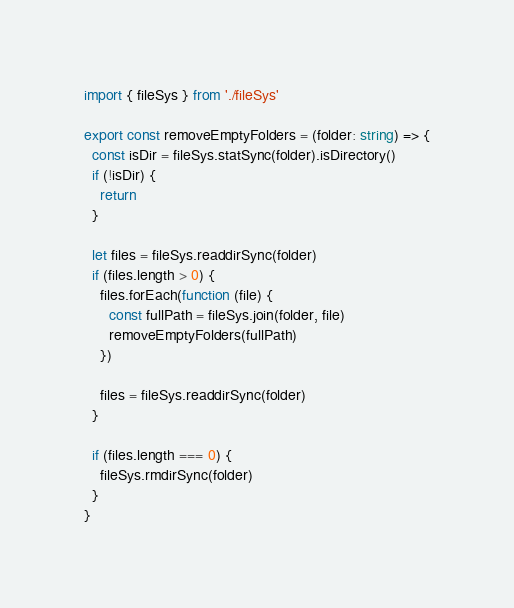<code> <loc_0><loc_0><loc_500><loc_500><_TypeScript_>import { fileSys } from './fileSys'

export const removeEmptyFolders = (folder: string) => {
  const isDir = fileSys.statSync(folder).isDirectory()
  if (!isDir) {
    return
  }

  let files = fileSys.readdirSync(folder)
  if (files.length > 0) {
    files.forEach(function (file) {
      const fullPath = fileSys.join(folder, file)
      removeEmptyFolders(fullPath)
    })

    files = fileSys.readdirSync(folder)
  }

  if (files.length === 0) {
    fileSys.rmdirSync(folder)
  }
}
</code> 